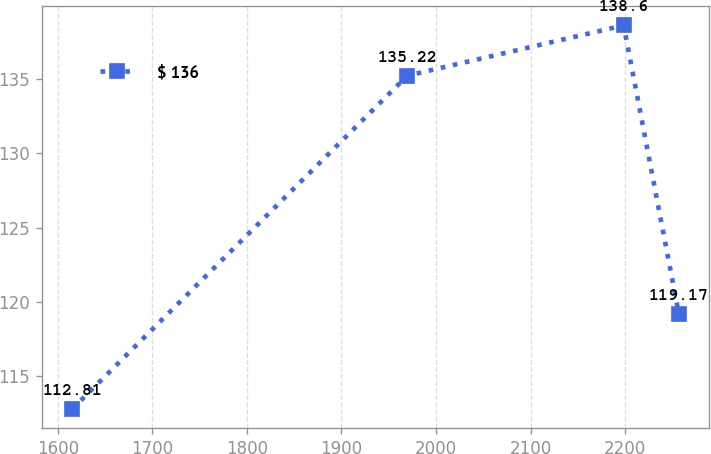Convert chart to OTSL. <chart><loc_0><loc_0><loc_500><loc_500><line_chart><ecel><fcel>$ 136<nl><fcel>1615.3<fcel>112.81<nl><fcel>1969.7<fcel>135.22<nl><fcel>2198.53<fcel>138.6<nl><fcel>2256.98<fcel>119.17<nl></chart> 